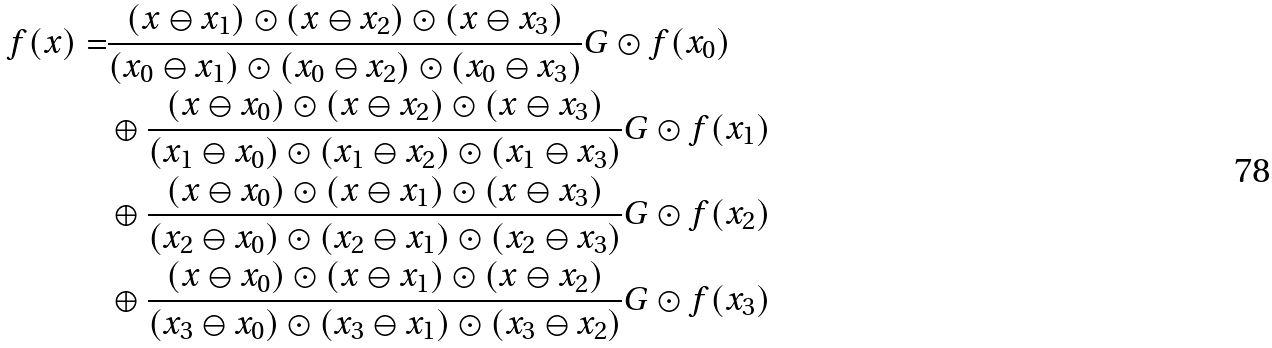<formula> <loc_0><loc_0><loc_500><loc_500>f ( x ) = & \frac { ( x \ominus x _ { 1 } ) \odot ( x \ominus x _ { 2 } ) \odot ( x \ominus x _ { 3 } ) } { ( x _ { 0 } \ominus x _ { 1 } ) \odot ( x _ { 0 } \ominus x _ { 2 } ) \odot ( x _ { 0 } \ominus x _ { 3 } ) } G \odot f ( x _ { 0 } ) \\ & \oplus \frac { ( x \ominus x _ { 0 } ) \odot ( x \ominus x _ { 2 } ) \odot ( x \ominus x _ { 3 } ) } { ( x _ { 1 } \ominus x _ { 0 } ) \odot ( x _ { 1 } \ominus x _ { 2 } ) \odot ( x _ { 1 } \ominus x _ { 3 } ) } G \odot f ( x _ { 1 } ) \\ & \oplus \frac { ( x \ominus x _ { 0 } ) \odot ( x \ominus x _ { 1 } ) \odot ( x \ominus x _ { 3 } ) } { ( x _ { 2 } \ominus x _ { 0 } ) \odot ( x _ { 2 } \ominus x _ { 1 } ) \odot ( x _ { 2 } \ominus x _ { 3 } ) } G \odot f ( x _ { 2 } ) \\ & \oplus \frac { ( x \ominus x _ { 0 } ) \odot ( x \ominus x _ { 1 } ) \odot ( x \ominus x _ { 2 } ) } { ( x _ { 3 } \ominus x _ { 0 } ) \odot ( x _ { 3 } \ominus x _ { 1 } ) \odot ( x _ { 3 } \ominus x _ { 2 } ) } G \odot f ( x _ { 3 } )</formula> 